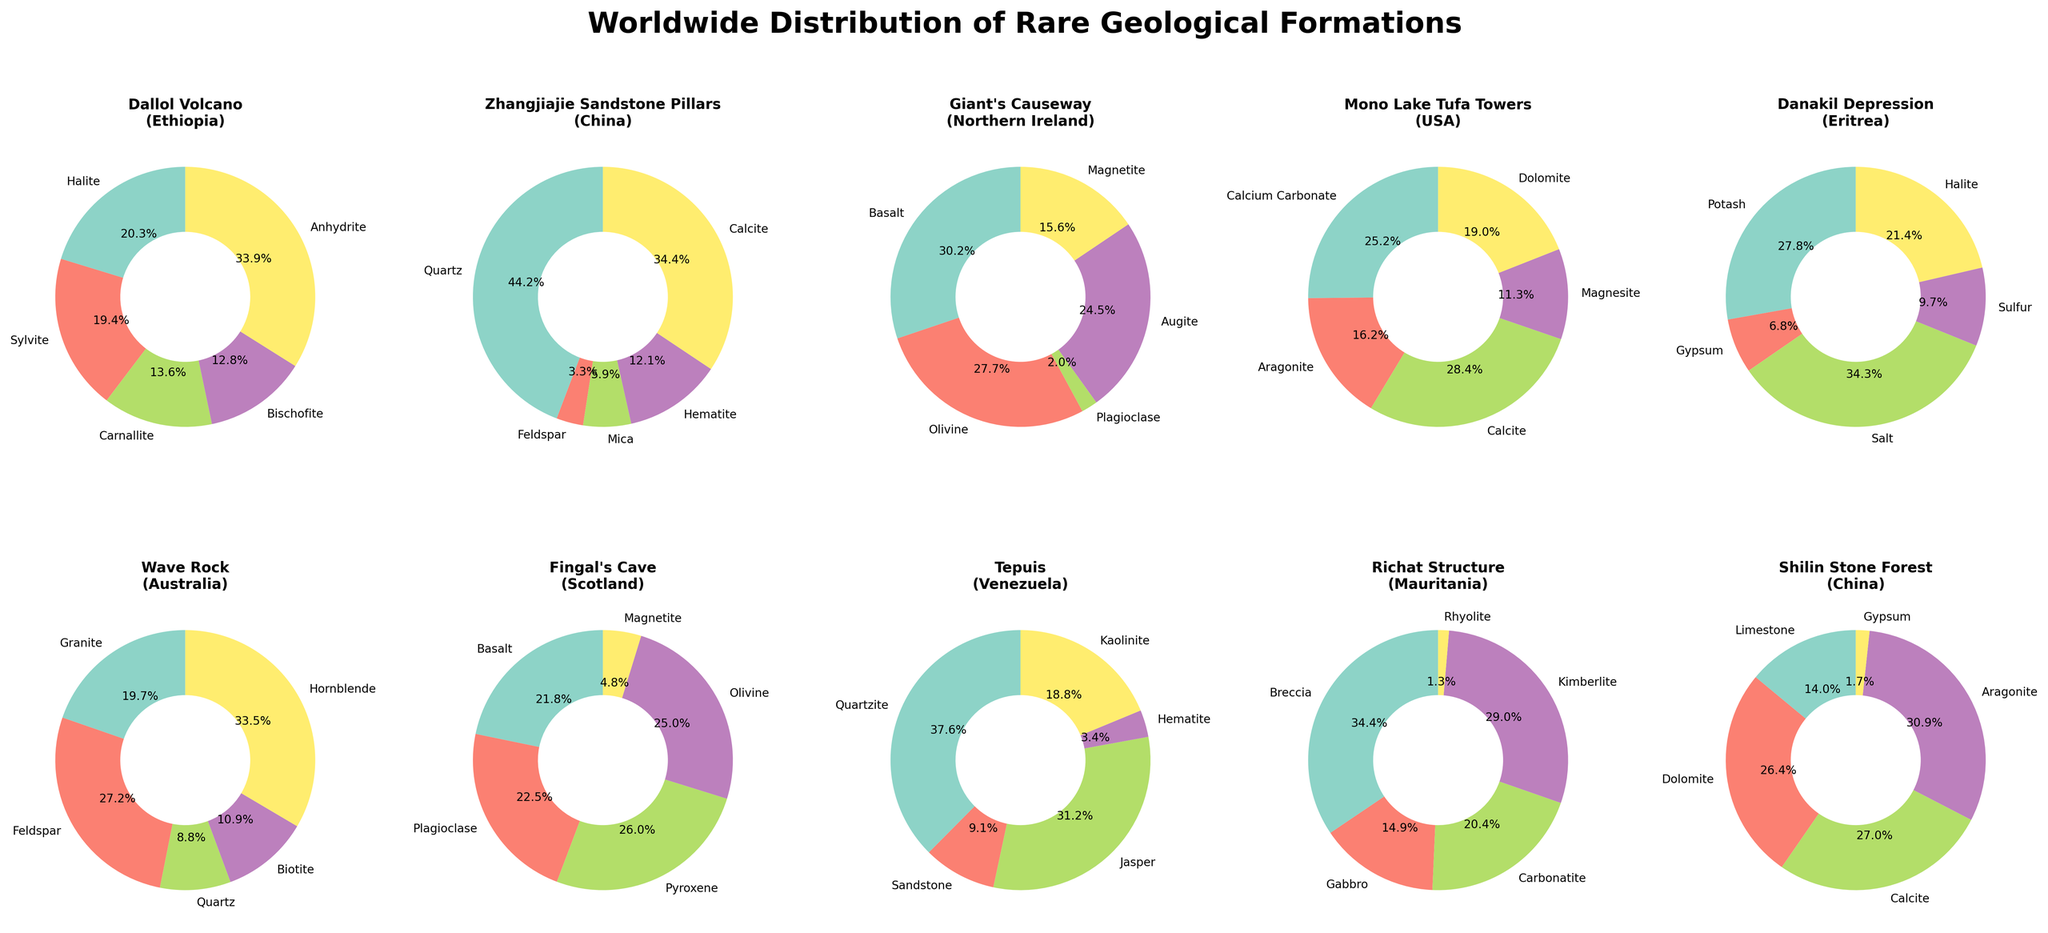What's the title of the figure? The title of the figure is displayed at the top of the plot.
Answer: Worldwide Distribution of Rare Geological Formations Which formation has Sylvite as one of its minerals? Look for slices labeled "Sylvite" in the pie charts. Sylvite is found in the Dallol Volcano pie chart.
Answer: Dallol Volcano What proportion of minerals in the 'Giant's Causeway' formation is Basalt? Find the 'Giant's Causeway' pie chart, then locate and read the wedge labeled "Basalt".
Answer: It varies (the exact percentage is generated randomly) How many subplots are there in the entire figure? Count the number of subplots in the grid. The figure has 2 rows and 5 columns, so 2 * 5 = 10 subplots.
Answer: 10 Which formation and location have the highest percentage of Quartz? Identify the formation whose pie chart slice labeled "Quartz" has the highest value. Compare the values shown for "Quartz" across different pie charts.
Answer: It varies (the exact percentage is generated randomly) Compare the mineral distributions of 'Zhangjiajie Sandstone Pillars' and 'Tepuis'. Which formation has a higher percentage of Hematite? Compare the pie charts for 'Zhangjiajie Sandstone Pillars' and 'Tepuis'. Look at the percentages for Hematite in each chart.
Answer: It varies (the exact percentage is generated randomly) How many minerals are common between the 'Danakil Depression' formation and the 'Mono Lake Tufa Towers' formation? Identify and count the minerals that appear in both subplots' legends for 'Danakil Depression' and 'Mono Lake Tufa Towers'.
Answer: 1 (Calcite) Calculate the total number of unique minerals listed in the figure. List all the minerals from each subplot, then count the distinct ones.
Answer: 25 (Halite, Sylvite, Carnallite, Bischofite, Anhydrite, Quartz, Feldspar, Mica, Hematite, Calcite, Basalt, Olivine, Plagioclase, Augite, Magnetite, Calcium Carbonate, Aragonite, Magnesite, Dolomite, Potash, Gypsum, Sulfur, Granite, Biotite, Hornblende) Which formation contains both "Plagioclase" and "Magnetite"? Locate the formations by checking each pie chart for both "Plagioclase" and "Magnetite".
Answer: Giant's Causeway and Fingal's Cave What mineral appears most frequently across all formations? Count the occurrences of each mineral across all subplots and identify the most frequent one.
Answer: Quartz 